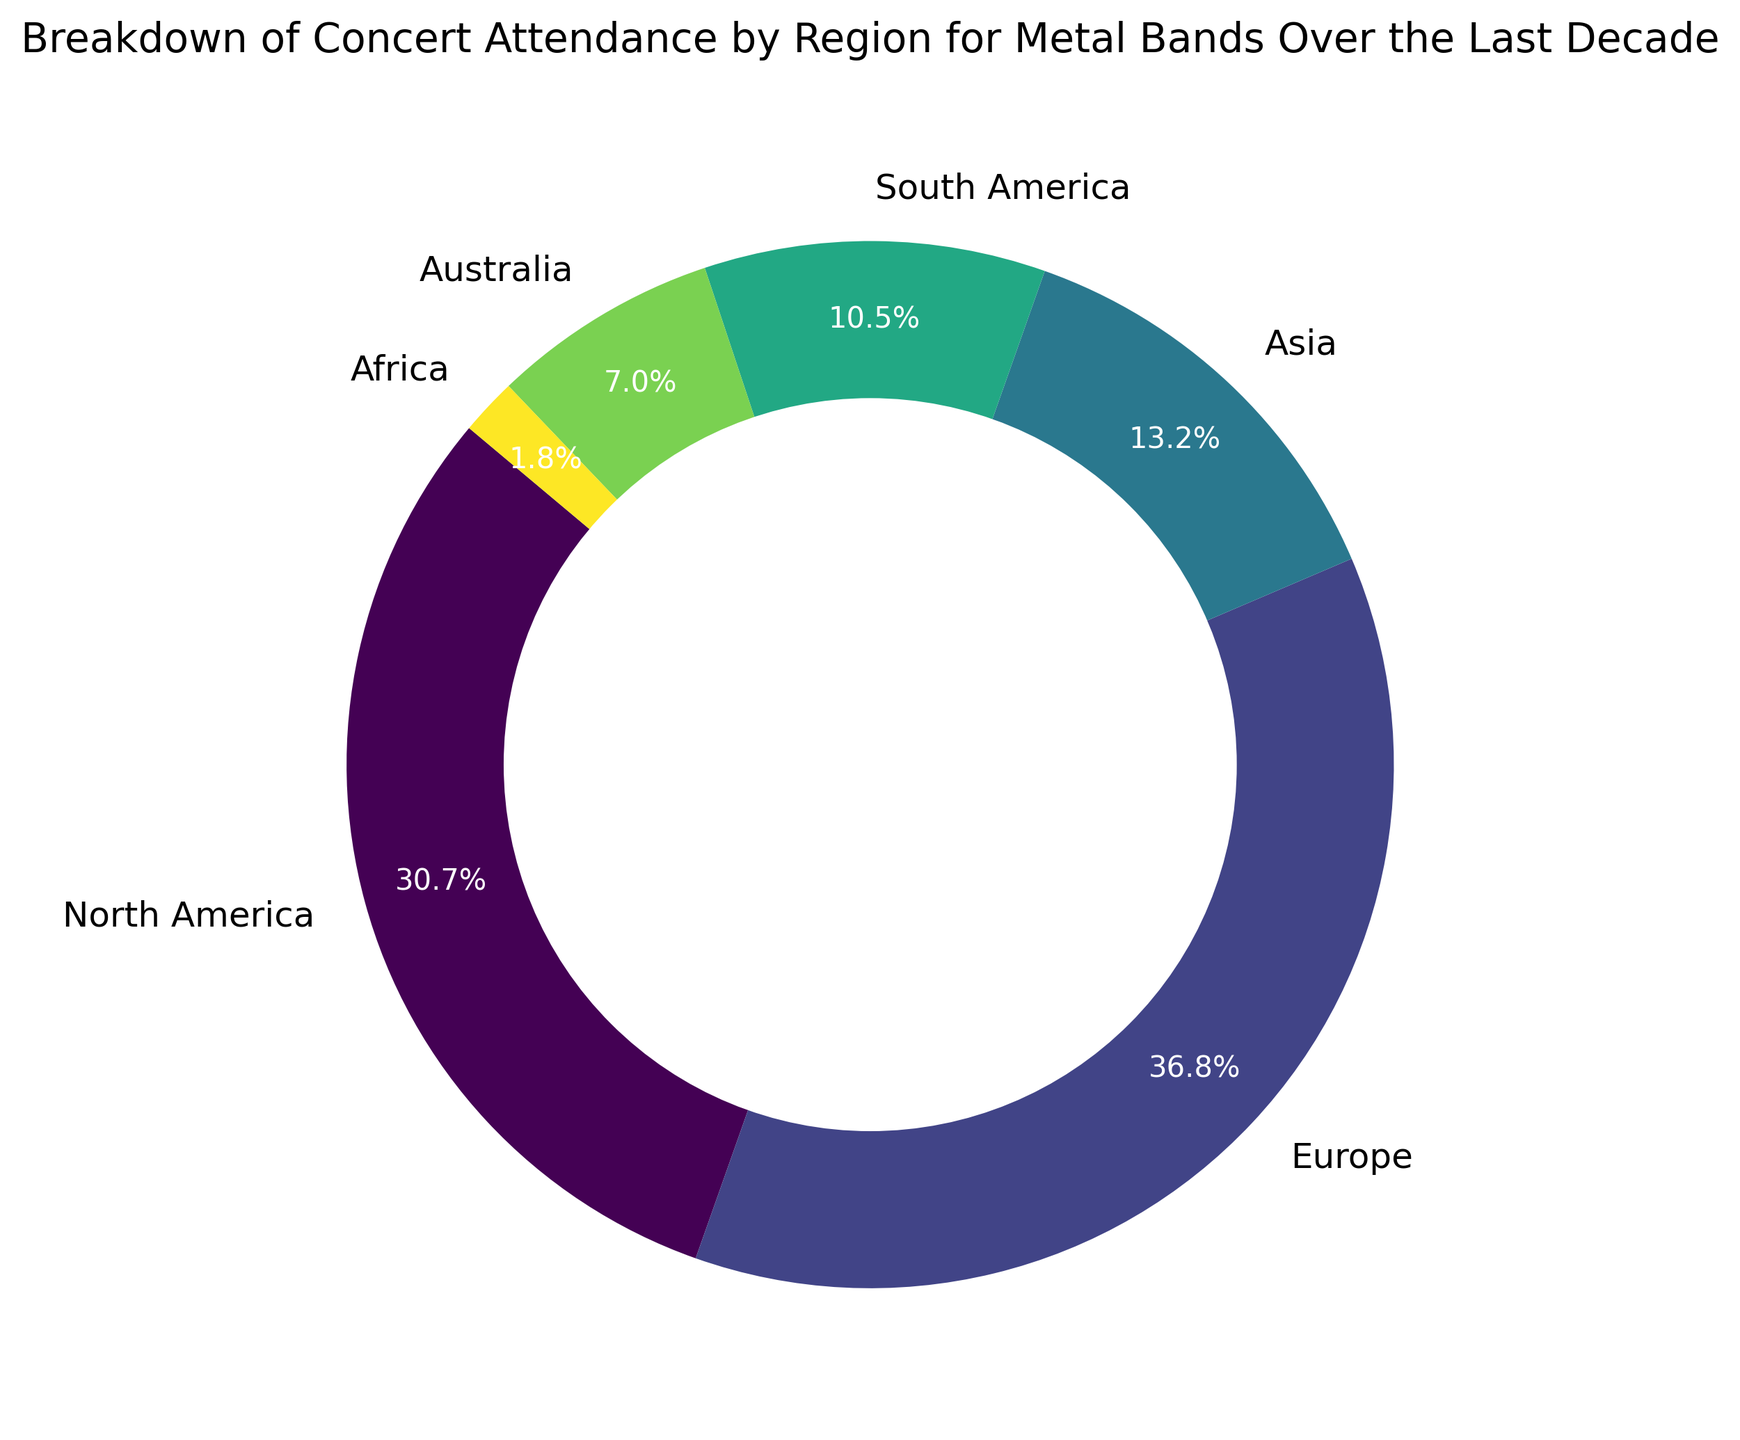Which region has the highest concert attendance for metal bands over the last decade? The figure shows different regions with their respective attendance percentages. Europe has the largest portion of the ring chart.
Answer: Europe What is the approximate total concert attendance for metal bands in North America and Asia combined over the last decade? North America's attendance is 3500000 and Asia's is 1500000. Adding these together gives 3500000 + 1500000 = 5000000.
Answer: 5000000 Which two regions together make up more than half of the total concert attendance? From the percentages shown on the ring chart, Europe is 42.0% and North America is 35.0%. Combined, they give 42.0 + 35.0 = 77.0%, which is more than half.
Answer: Europe and North America How does South America's concert attendance compare to that of Australia? The chart shows South America's attendance as 12.0% and Australia's as 8.0%. Therefore, South America's attendance is higher than Australia's.
Answer: South America's attendance is higher What is the difference between the concert attendance in Europe and South America? Europe's attendance is 4200000 and South America's is 1200000. Subtracting these gives 4200000 - 1200000 = 3000000.
Answer: 3000000 What percentage of the total attendance is represented by Africa? The ring chart shows Africa's attendance as 2.0%.
Answer: 2.0% If total concert attendance was 11400000, what is the actual number of attendees in Australia? Australia's percentage of the total attendance is 8.0%. Multiplying this percentage by the total attendance gives 0.08 * 11400000 = 912000.
Answer: 912000 Which region has the smallest concert attendance, and what is its percentage? Africa has the smallest segment on the ring chart, which represents 2.0% of the total attendance.
Answer: Africa, 2.0% Among the regions, which ones have concert attendances exceeding one million attendees? The regions are given as North America (3500000), Europe (4200000), Asia (1500000), and South America (1200000).
Answer: North America, Europe, Asia, and South America What is the combined percentage of concert attendance for Asia, South America, and Australia? The chart shows Asia as 15.0%, South America as 12.0%, and Australia as 8.0%. Adding these percentages gives 15.0 + 12.0 + 8.0 = 35.0%.
Answer: 35.0% 